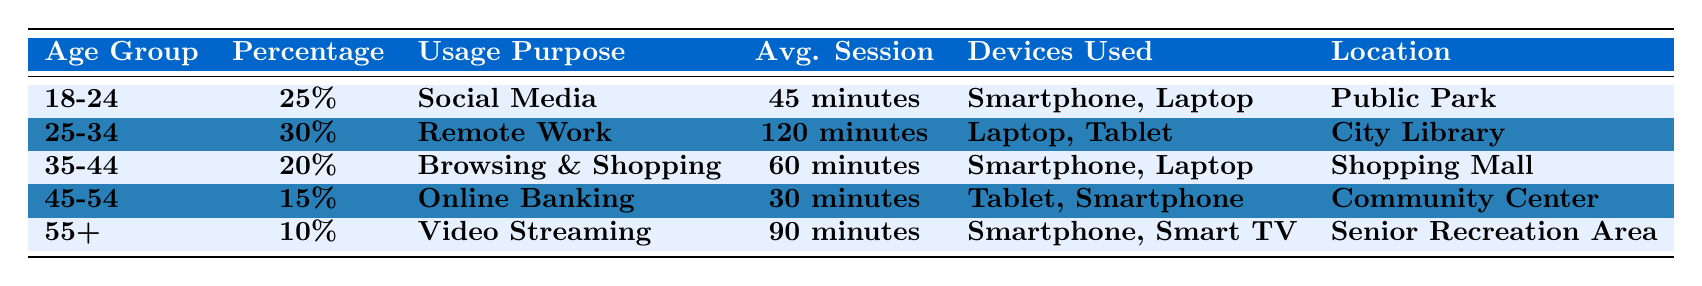What is the average session duration for users in the 25-34 age group? The average session duration for the 25-34 age group is listed as 120 minutes in the table.
Answer: 120 minutes Which age group has the highest percentage of users accessing free Wi-Fi? The age group 25-34 has the highest percentage at 30% according to the table.
Answer: 25-34 What percentage of users aged 45-54 use free Wi-Fi for online banking? The percentage of users aged 45-54 accessing free Wi-Fi for online banking is 15% as shown in the table.
Answer: 15% Is the usage purpose for the 55+ age group related to social media? No, the usage purpose for the 55+ age group is video streaming, not social media, according to the data provided.
Answer: No What is the total percentage of users aged 18-24 and 35-44 using free Wi-Fi? Summing the percentages: 25% (18-24) + 20% (35-44) = 45%. Therefore, the total percentage is 45%.
Answer: 45% Which location has the longest average session duration? The location City Library for the 25-34 age group has the longest average session duration of 120 minutes.
Answer: City Library If users aged 18-24 and 45-54 were to combine their usage percentages, how much would that be? Adding the percentages gives: 25% (18-24) + 15% (45-54) = 40%. Therefore, the combined percentage is 40%.
Answer: 40% How many different devices are reported as used by individuals in the 35-44 age group? The devices listed for the 35-44 age group are smartphone and laptop, which totals to 2 different devices.
Answer: 2 Which two age groups use smartphones according to the data? The age groups that use smartphones are 18-24 and 35-44 according to the devices used listed in the table.
Answer: 18-24 and 35-44 What is the purpose of usage for the age group 55+? The purpose of usage for the 55+ age group is video streaming, as shown in the table.
Answer: Video Streaming 